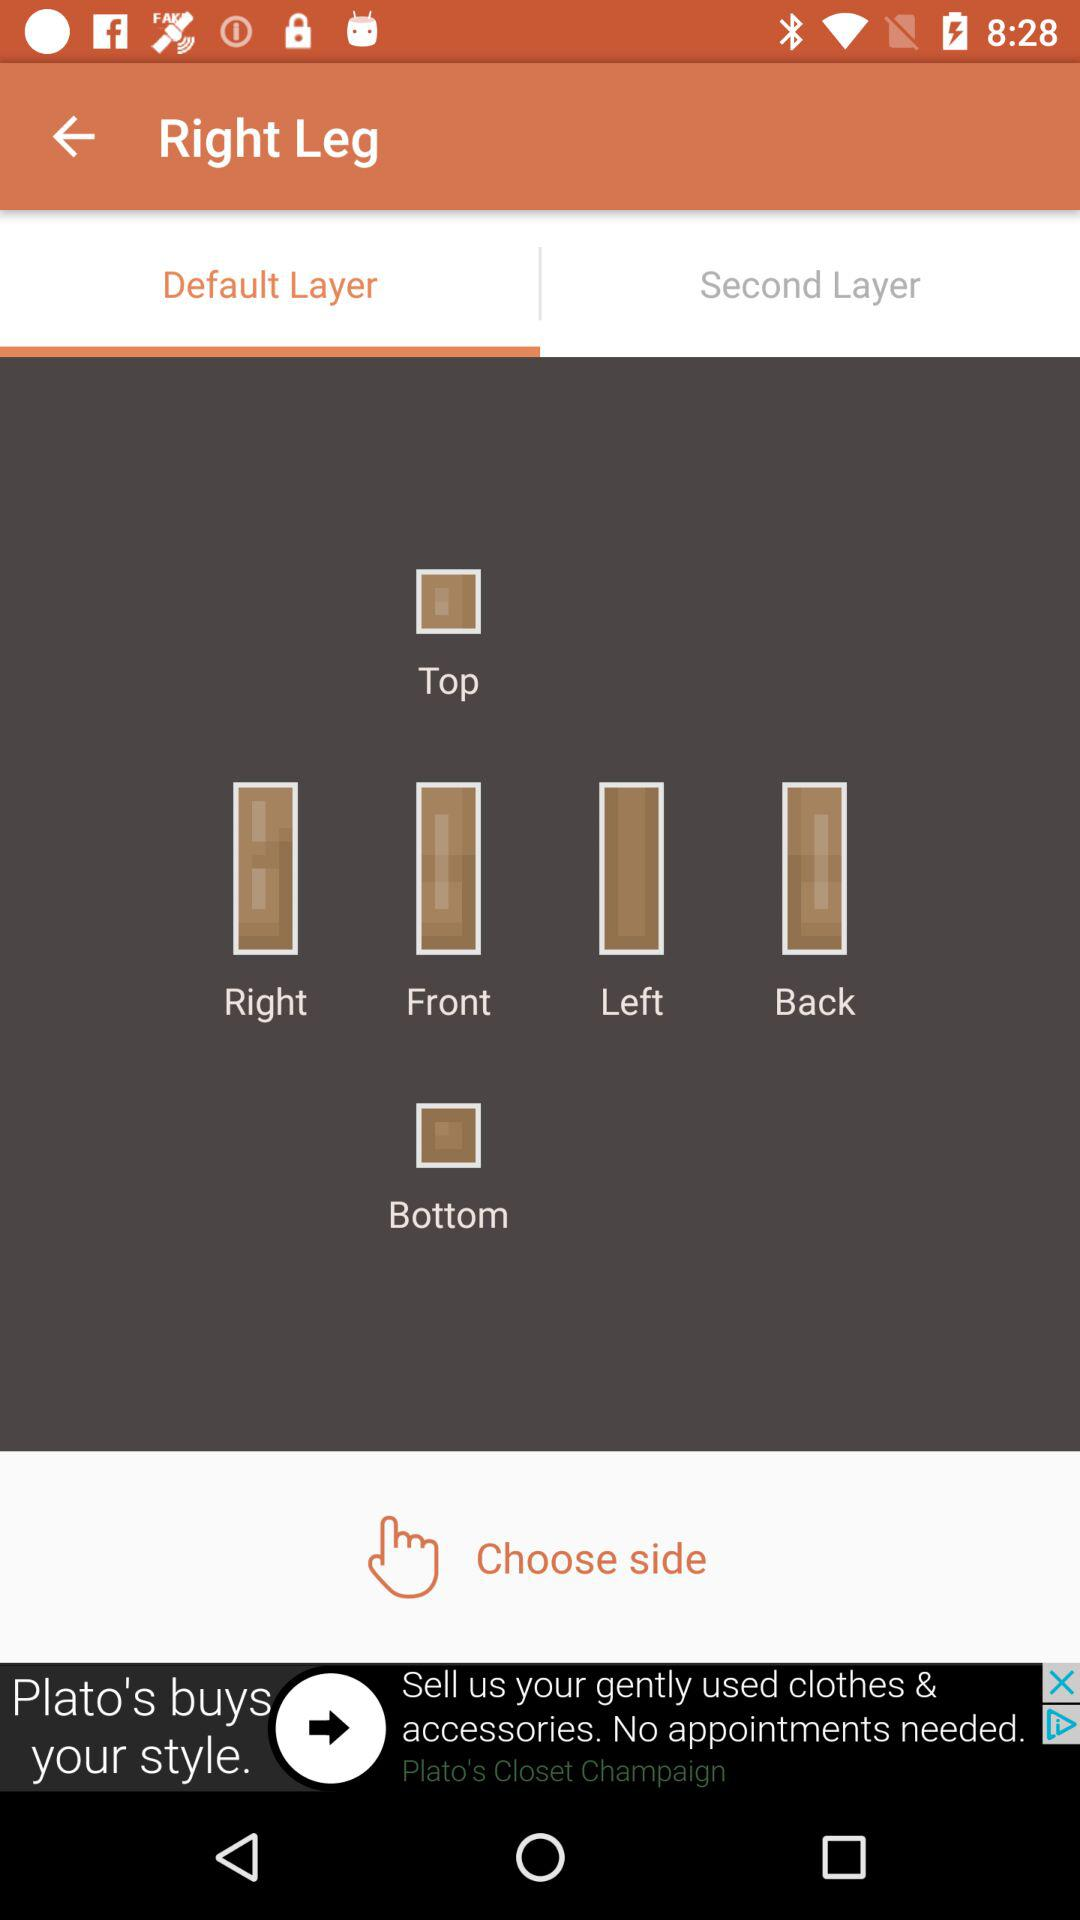How many layers are available?
Answer the question using a single word or phrase. 2 